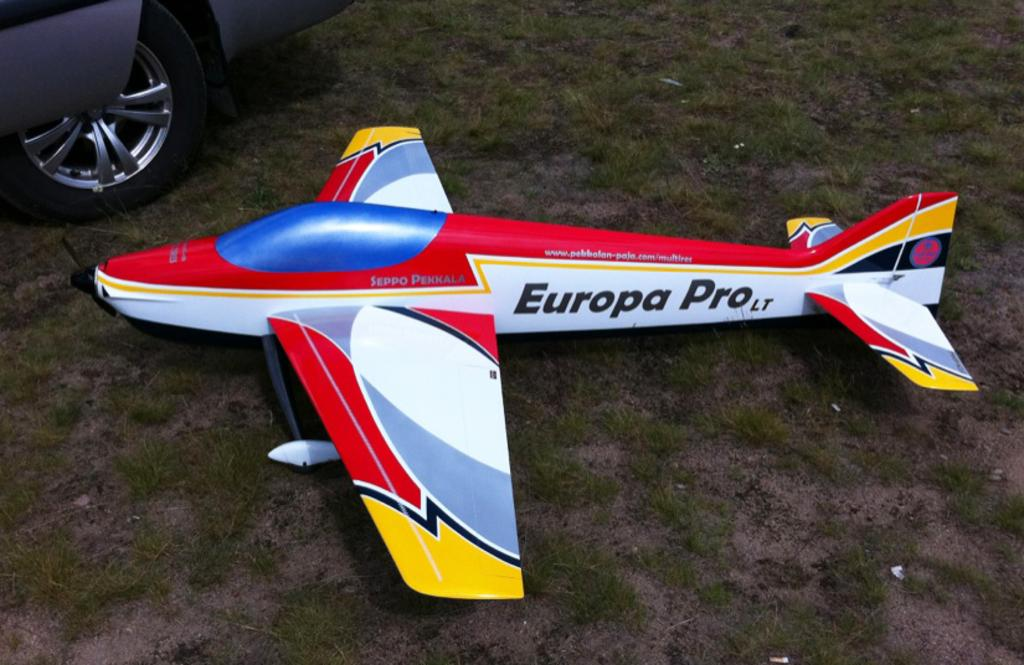Provide a one-sentence caption for the provided image. A model airplane called the Europa Pro is sitting on the ground outside. 